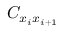<formula> <loc_0><loc_0><loc_500><loc_500>C _ { x _ { i } x _ { i + 1 } }</formula> 